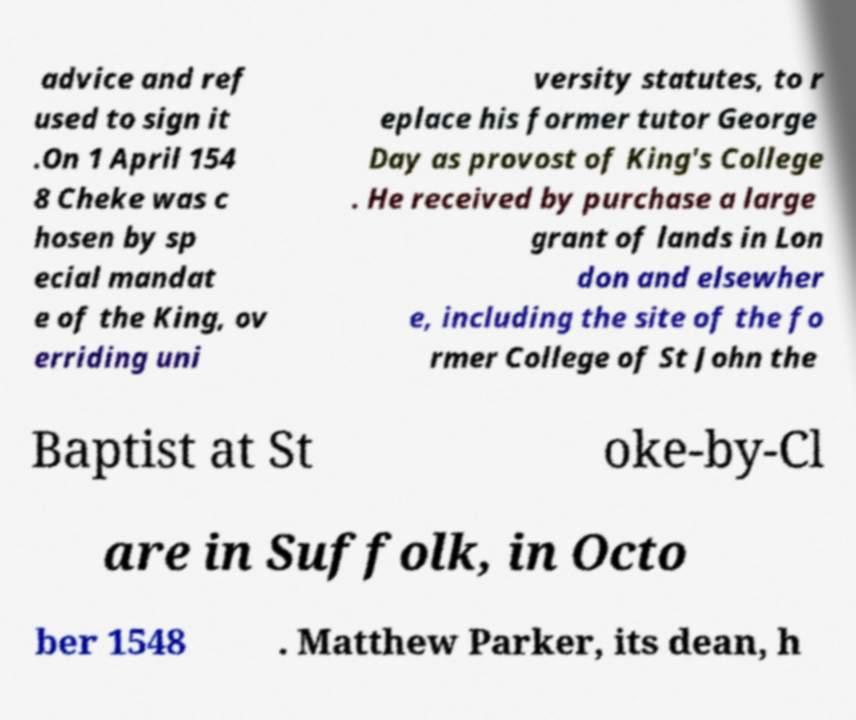There's text embedded in this image that I need extracted. Can you transcribe it verbatim? advice and ref used to sign it .On 1 April 154 8 Cheke was c hosen by sp ecial mandat e of the King, ov erriding uni versity statutes, to r eplace his former tutor George Day as provost of King's College . He received by purchase a large grant of lands in Lon don and elsewher e, including the site of the fo rmer College of St John the Baptist at St oke-by-Cl are in Suffolk, in Octo ber 1548 . Matthew Parker, its dean, h 